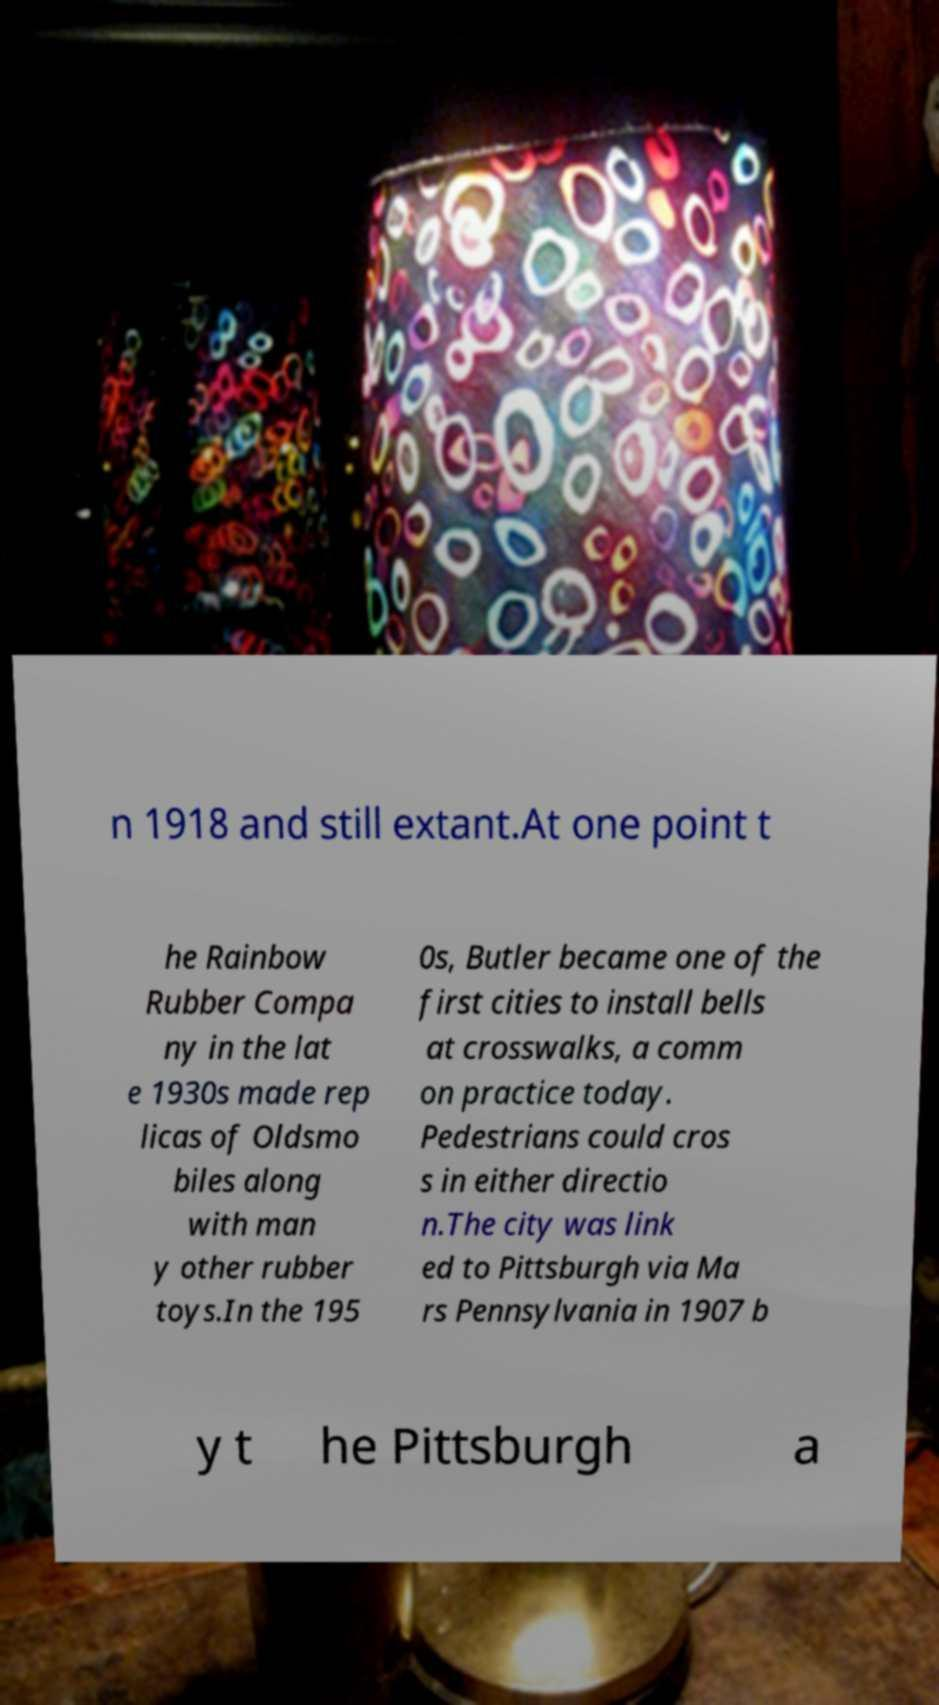Please identify and transcribe the text found in this image. n 1918 and still extant.At one point t he Rainbow Rubber Compa ny in the lat e 1930s made rep licas of Oldsmo biles along with man y other rubber toys.In the 195 0s, Butler became one of the first cities to install bells at crosswalks, a comm on practice today. Pedestrians could cros s in either directio n.The city was link ed to Pittsburgh via Ma rs Pennsylvania in 1907 b y t he Pittsburgh a 